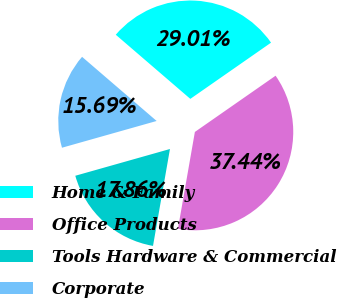Convert chart. <chart><loc_0><loc_0><loc_500><loc_500><pie_chart><fcel>Home & Family<fcel>Office Products<fcel>Tools Hardware & Commercial<fcel>Corporate<nl><fcel>29.01%<fcel>37.44%<fcel>17.86%<fcel>15.69%<nl></chart> 